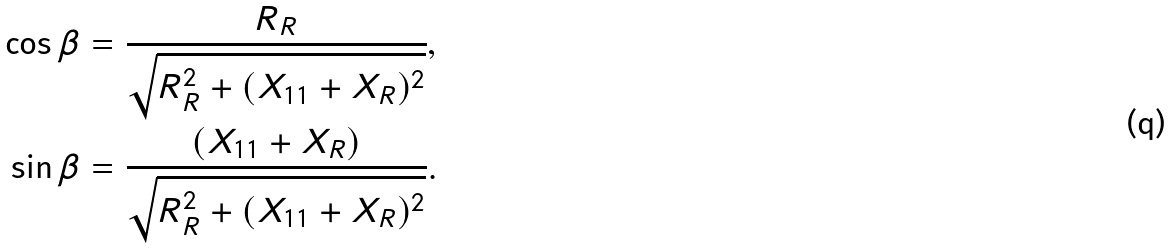Convert formula to latex. <formula><loc_0><loc_0><loc_500><loc_500>\cos \beta & = \frac { R _ { R } } { \sqrt { R _ { R } ^ { 2 } + ( X _ { 1 1 } + X _ { R } ) ^ { 2 } } } , \\ \sin \beta & = \frac { ( X _ { 1 1 } + X _ { R } ) } { \sqrt { R _ { R } ^ { 2 } + ( X _ { 1 1 } + X _ { R } ) ^ { 2 } } } .</formula> 